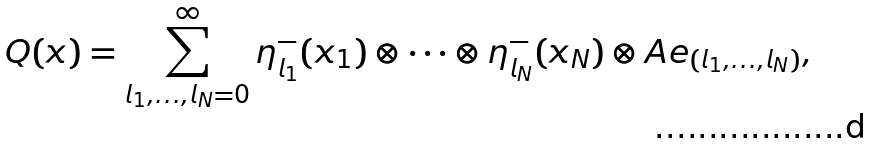Convert formula to latex. <formula><loc_0><loc_0><loc_500><loc_500>Q ( x ) = \sum _ { l _ { 1 } , \dots , l _ { N } = 0 } ^ { \infty } \eta _ { l _ { 1 } } ^ { - } ( x _ { 1 } ) \otimes \cdots \otimes \eta _ { l _ { N } } ^ { - } ( x _ { N } ) \otimes A e _ { ( l _ { 1 } , \dots , l _ { N } ) } ,</formula> 